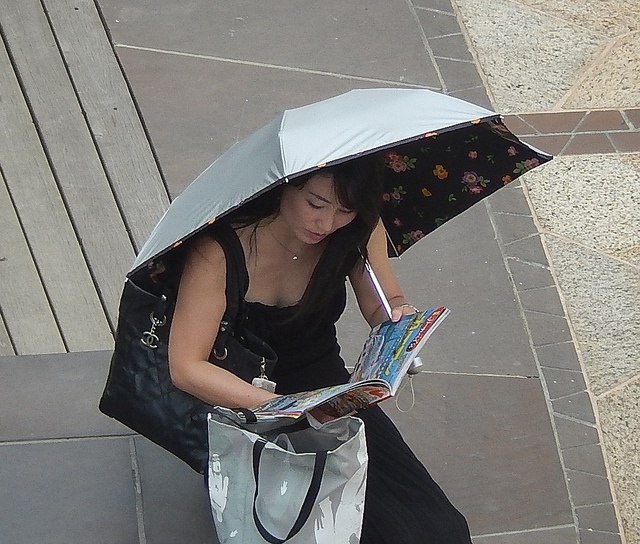Describe the objects in this image and their specific colors. I can see people in gray, black, and darkgray tones, umbrella in gray, black, lightgray, and darkgray tones, handbag in gray, darkgray, and black tones, handbag in gray, black, and darkgray tones, and book in gray, darkgray, black, and lightgray tones in this image. 